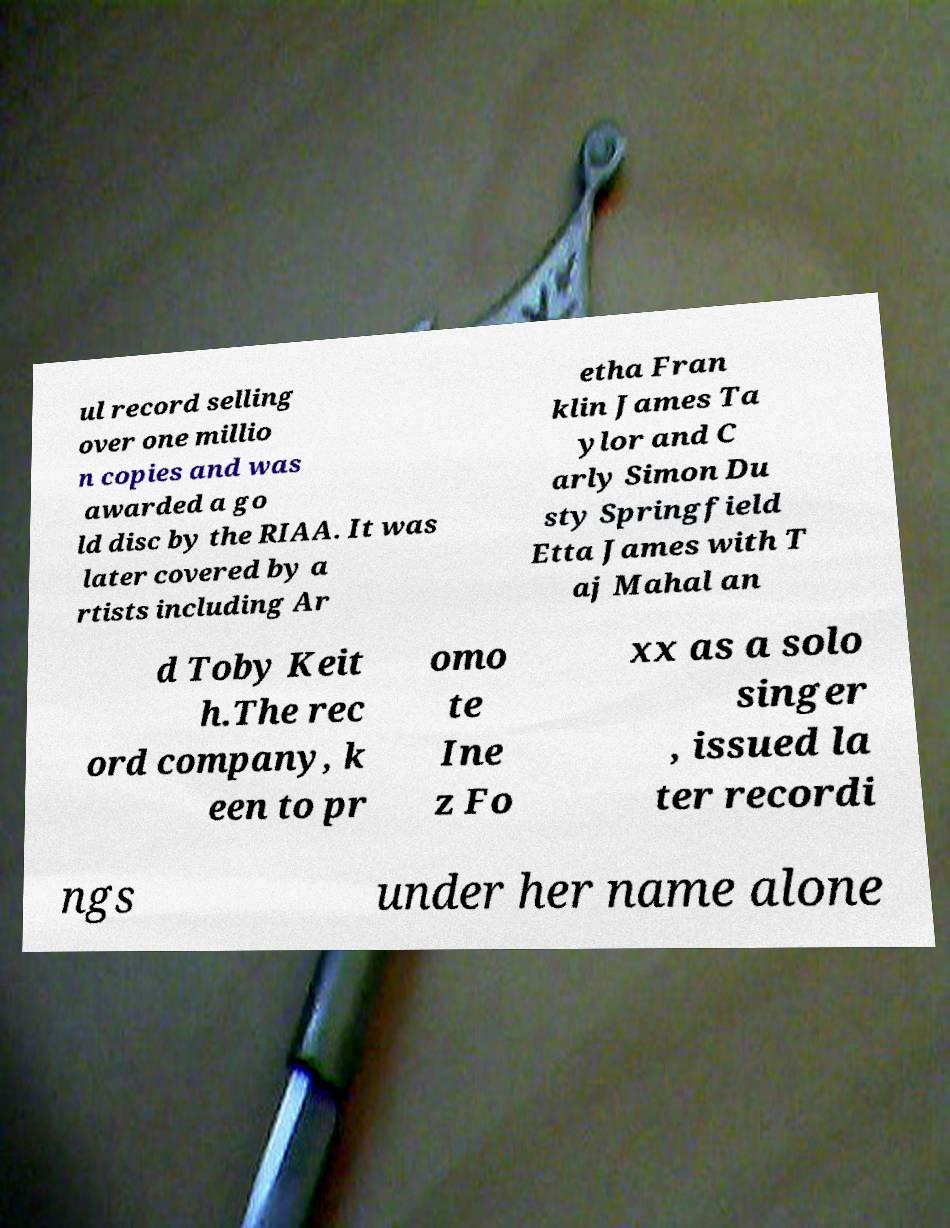Please read and relay the text visible in this image. What does it say? ul record selling over one millio n copies and was awarded a go ld disc by the RIAA. It was later covered by a rtists including Ar etha Fran klin James Ta ylor and C arly Simon Du sty Springfield Etta James with T aj Mahal an d Toby Keit h.The rec ord company, k een to pr omo te Ine z Fo xx as a solo singer , issued la ter recordi ngs under her name alone 